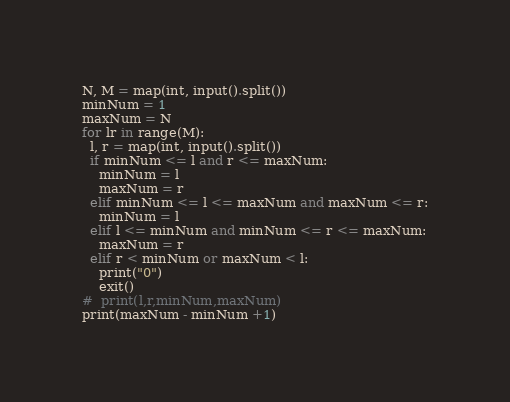<code> <loc_0><loc_0><loc_500><loc_500><_Python_>N, M = map(int, input().split())
minNum = 1
maxNum = N
for lr in range(M):
  l, r = map(int, input().split())
  if minNum <= l and r <= maxNum:
    minNum = l
    maxNum = r
  elif minNum <= l <= maxNum and maxNum <= r:
    minNum = l
  elif l <= minNum and minNum <= r <= maxNum:
    maxNum = r
  elif r < minNum or maxNum < l:
    print("0")
    exit()
#  print(l,r,minNum,maxNum)
print(maxNum - minNum +1)
</code> 